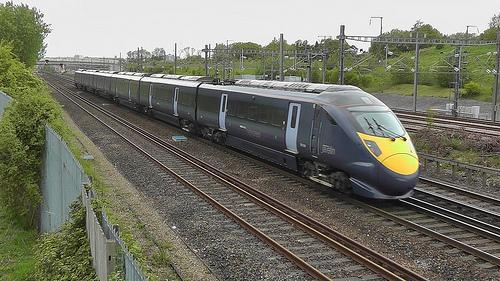Name the objects in the picture that can be counted for analysis. Trains, train tracks, train doors, trees, power lines, and fences can be counted for object counting tasks. Count the number of trains in the image and provide a brief description of each. There is one train in the image, which is long and mostly blue with some yellow near the front. How could complex reasoning tasks be applied to the elements in this image? Complex reasoning tasks could involve predicting the train's speed or direction, understanding the relationship between the train doors and passengers, or determining the purpose of specific train features. Describe the landscaping around the train tracks in the image. There are green trees, shrubs climbing a wooden fence, a patch of grass, and brown gravel next to the train tracks. A grey fence and power lines are also visible. Discuss how object interaction analysis could be conducted for this image. Object interaction analysis can be conducted by examining the relationships between the trains, tracks, and surrounding scenery, such as trees and fences. What type of analysis can be done to understand the sentiment of the image? Perform an image sentiment analysis task to determine the mood conveyed by the colors, scenery, and objects within the image. What are the main colors of the trains and the sky in the image? The train is primarily blue with some yellow, while the sky appears to be grey and overcast. What kind of question could be asked to understand the quality of the image? Analyze the sharpness, exposure, and color balance of the image to assess its quality through an image quality assessment task. Is the train in the top-right corner of the image, surrounded by trees? Yes, the train is visible in the top-right corner of the image, running along the tracks and partially surrounded by trees. Is there a person waiting next to the door of the train? No, there is no person visible next to the door of the train in the image. Can you see a bright red train with white stripes on it? No, the train in the image is blue with yellow accents; there is no bright red train with white stripes visible. 